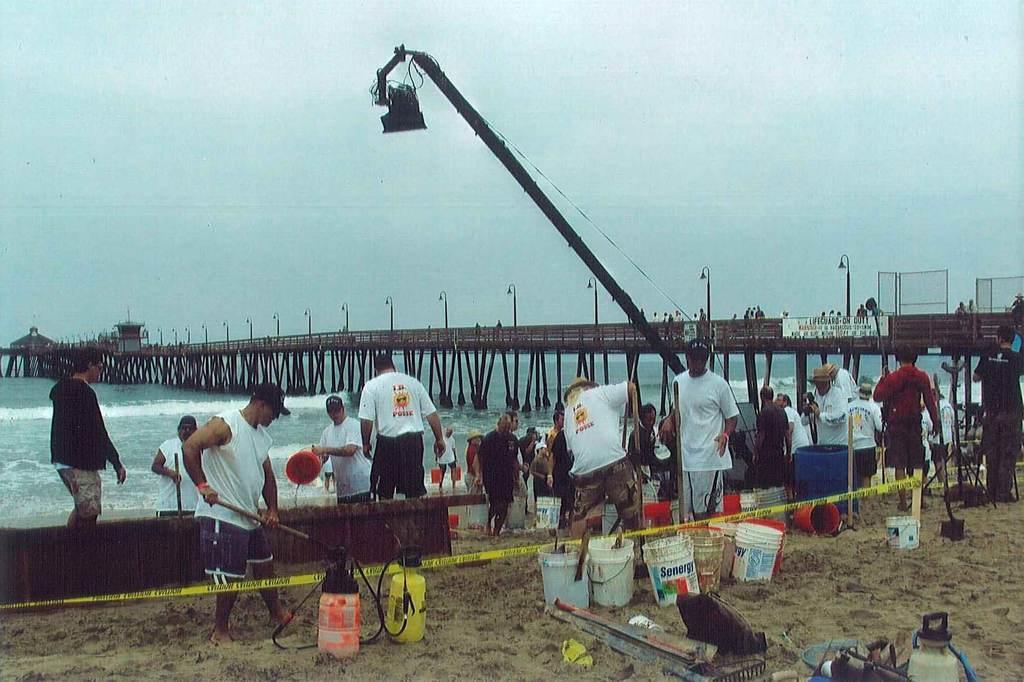Could you give a brief overview of what you see in this image? In this image in front there are buckets and a few other objects on the sand. On the backside there are people standing on the sand. At the center of the image there is water and we can see bridge, crane and lights. In the background there is sky. 